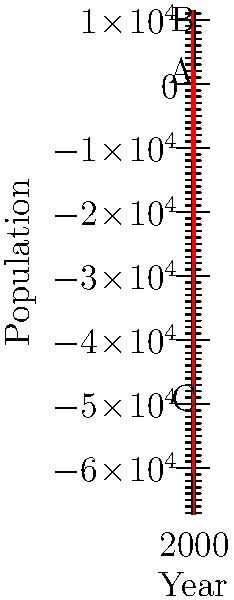The graph represents the population of our tribe over the past 400 years. The function $f(x) = 0.0001(x-1600)(x-1700)(x-1800)(x-2000) + 2000$ models our population, where $x$ is the year. What significant event in our history likely caused the population decline at point B, and approximately when did it occur? To answer this question, we need to analyze the graph and interpret its meaning in the context of our tribal history:

1. The graph shows population changes from 1600 to 2000.
2. Point B represents a local minimum on the graph, indicating a significant population decline.
3. To find the year corresponding to point B, we need to estimate its x-coordinate.
4. Visually, point B appears to be around 1770.
5. This time period coincides with increased European colonization and conflicts.
6. The population decline at point B likely represents the impact of diseases brought by Europeans or conflicts resulting from colonization.
7. After point B, the population begins to recover, possibly due to adaptation and resistance to new diseases.

Therefore, the significant event causing the population decline at point B is likely the impact of European colonization, occurring around 1770.
Answer: European colonization, circa 1770 